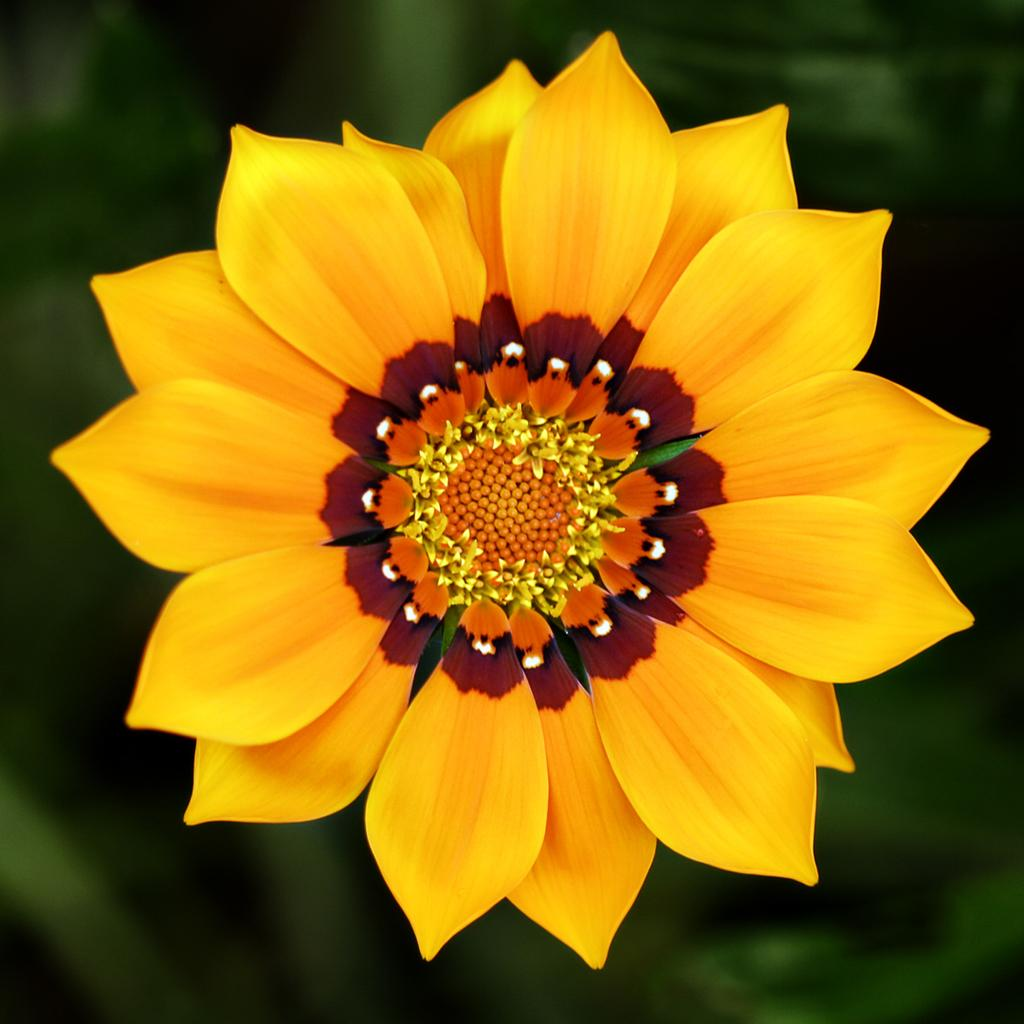What type of flower is in the image? There is a yellow flower in the image. Can you describe the background of the image? The background of the image is blurred. What type of structure can be seen in the background of the image? There is no structure visible in the background of the image; it is blurred. What type of thing is the yellow flower placed in? The facts provided do not mention a container or basket for the flower, so we cannot determine if it is placed in a thing or not. 